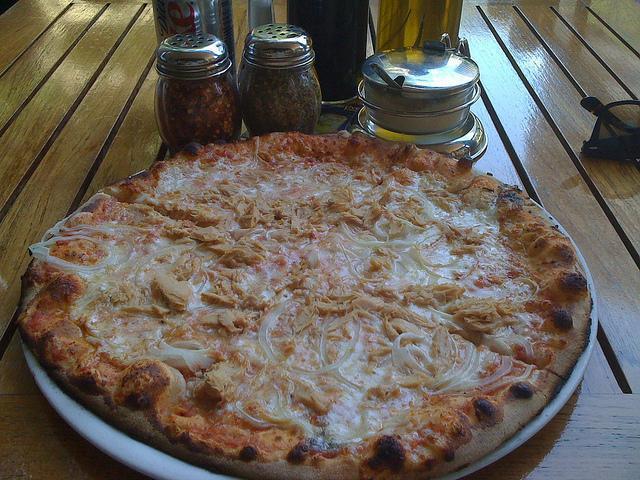How many bottles can you see?
Give a very brief answer. 4. How many bowls are visible?
Give a very brief answer. 1. 